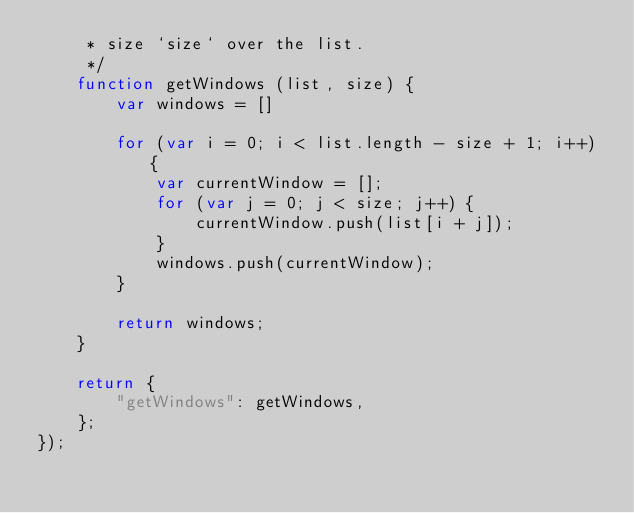<code> <loc_0><loc_0><loc_500><loc_500><_JavaScript_>     * size `size` over the list.
     */
    function getWindows (list, size) {
        var windows = []

        for (var i = 0; i < list.length - size + 1; i++) {
            var currentWindow = [];
            for (var j = 0; j < size; j++) {
                currentWindow.push(list[i + j]);
            }
            windows.push(currentWindow);
        }

        return windows;
    }

    return {
        "getWindows": getWindows,
    };
});
</code> 